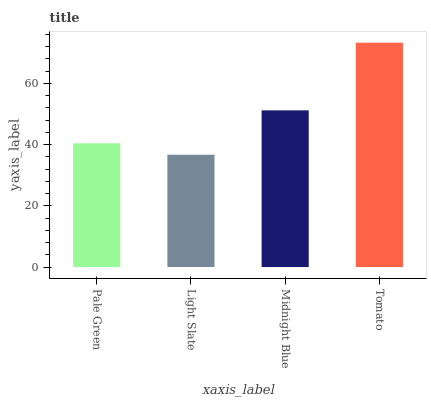Is Light Slate the minimum?
Answer yes or no. Yes. Is Tomato the maximum?
Answer yes or no. Yes. Is Midnight Blue the minimum?
Answer yes or no. No. Is Midnight Blue the maximum?
Answer yes or no. No. Is Midnight Blue greater than Light Slate?
Answer yes or no. Yes. Is Light Slate less than Midnight Blue?
Answer yes or no. Yes. Is Light Slate greater than Midnight Blue?
Answer yes or no. No. Is Midnight Blue less than Light Slate?
Answer yes or no. No. Is Midnight Blue the high median?
Answer yes or no. Yes. Is Pale Green the low median?
Answer yes or no. Yes. Is Pale Green the high median?
Answer yes or no. No. Is Light Slate the low median?
Answer yes or no. No. 